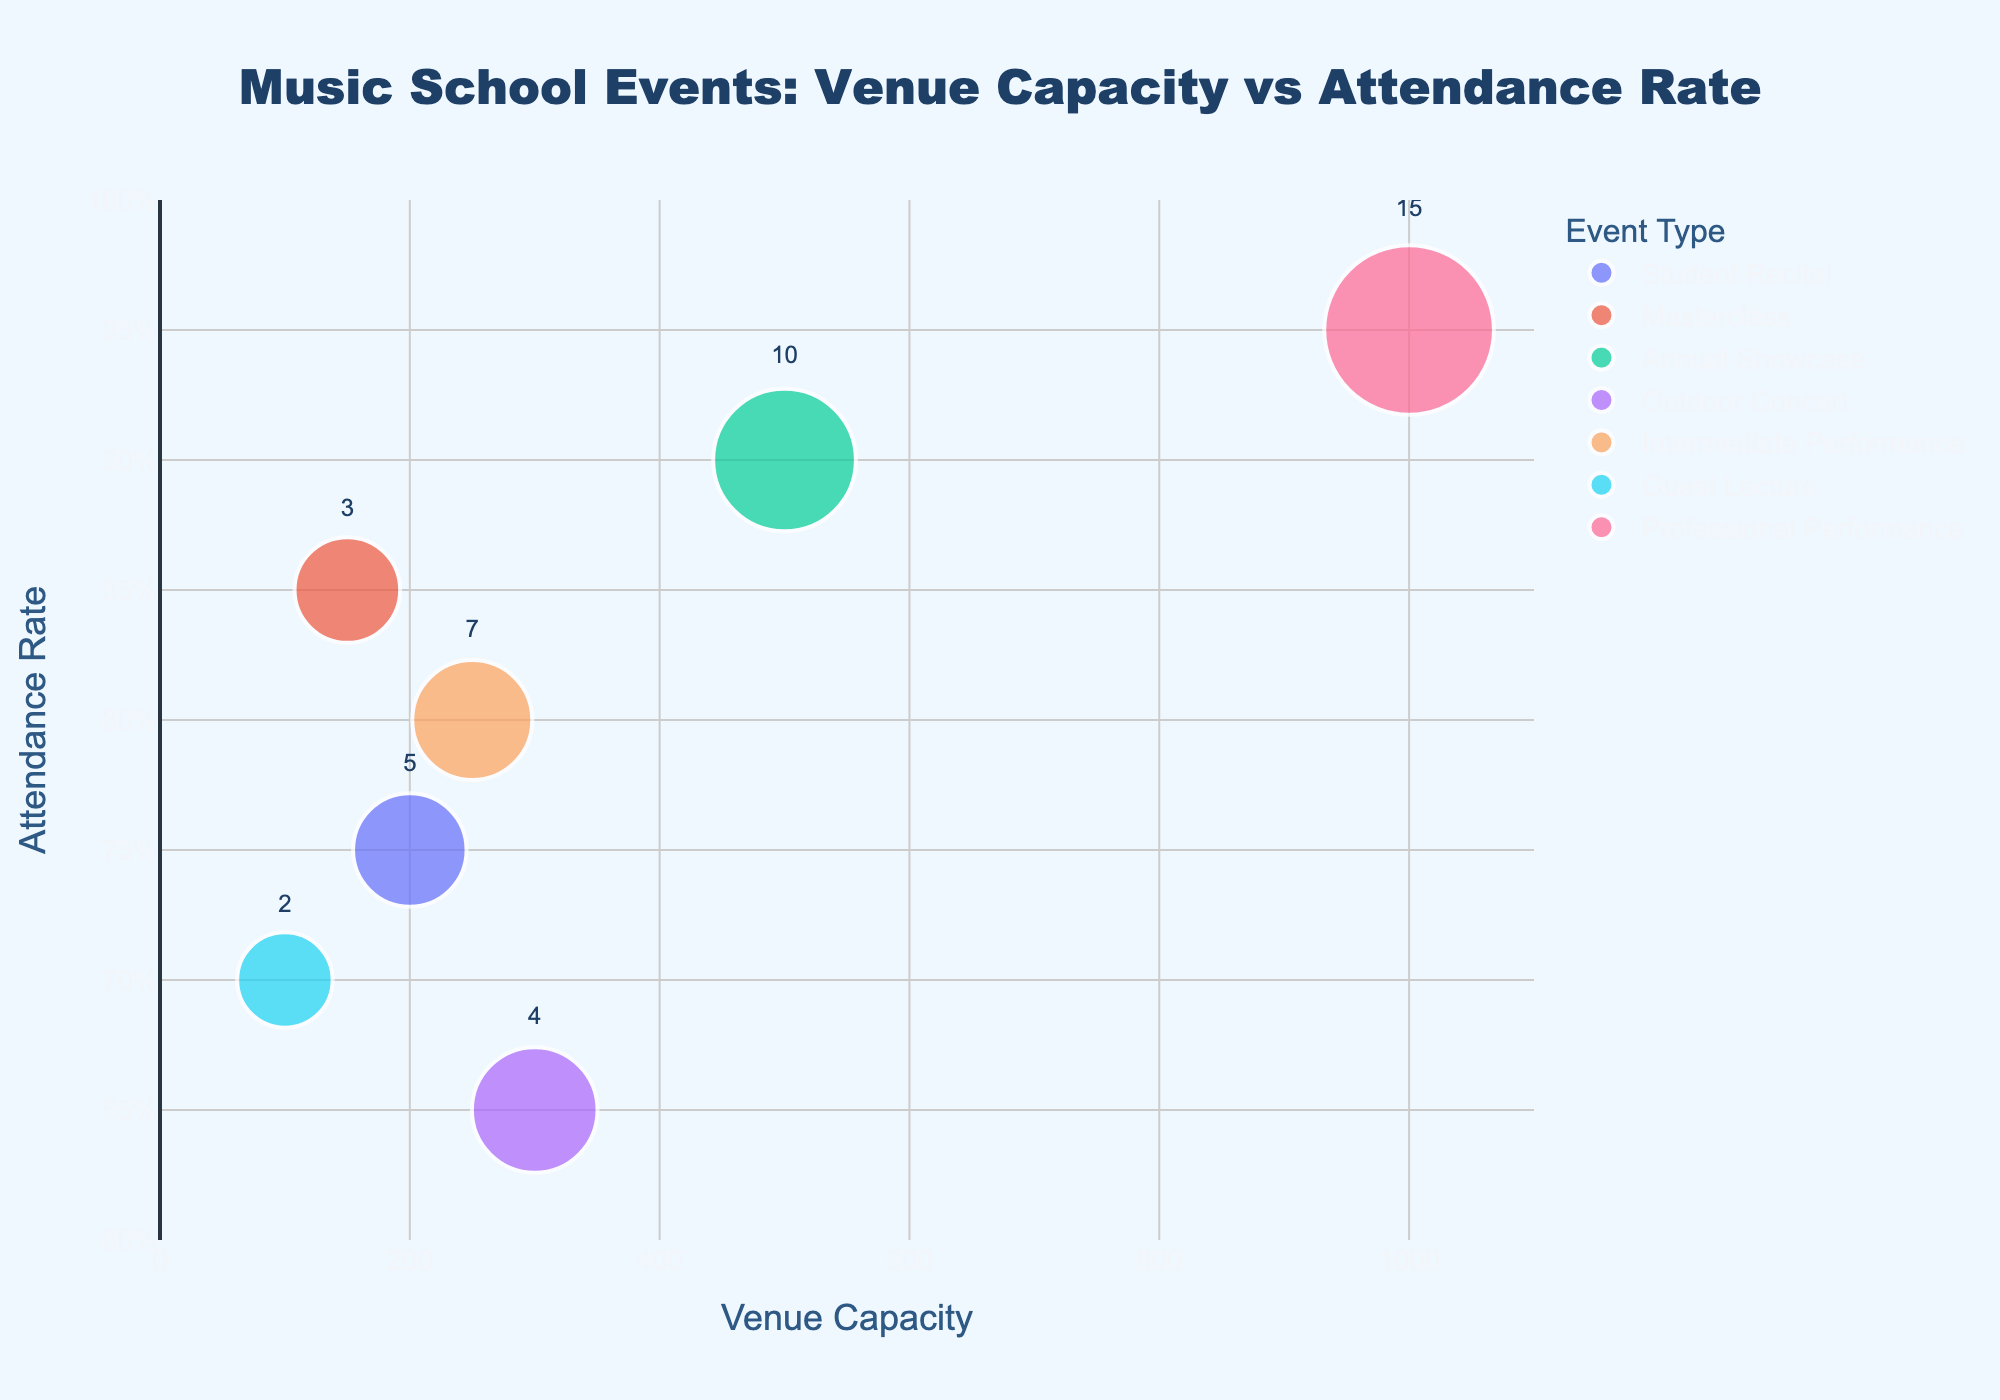What's the venue with the highest capacity? By examining the x-axis and the bubble sizes, the Concert Hall has the highest capacity at 1000.
Answer: Concert Hall Which event type has the highest attendance rate overall? The event type with the highest attendance rate is observed by looking at the y-axis. The Concert Hall's Professional Performance has the highest attendance rate at 0.95 (95%).
Answer: Professional Performance How many scholarship recipients are there for the event at the Local Park? The text label inside the bubble for Local Park, which is an Outdoor Concert, indicates the number of scholarship recipients. It shows 4.
Answer: 4 Which two venues have approximately the same attendance rate, and what is it? Observing the y-axis and the positions of the bubbles, the Community Center (Masterclass) and the High School Auditorium (Intermediate Performance) both have attendance rates around 0.80.
Answer: Community Center and High School Auditorium; 0.80 What is the difference in capacity between the Town Hall and the Community Center? The Town Hall has a capacity of 200 and the Community Center has a capacity of 150. The difference is calculated as 200 - 150 = 50.
Answer: 50 Which event type has the widest range of capacities? By comparing the x-axis range for each event type, Professional Performance (Concert Hall) ranges up to 1000 and the smallest venue Guest Lecture (Library Auditorium) ranges to 100.
Answer: Professional Performance On average, how many scholarship recipients are awarded per event? Sum the number of scholarship recipients for all events (5 + 3 + 10 + 4 + 7 + 2 + 15 = 46) and divide by the number of events (7). The average is 46 / 7 ≈ 6.57.
Answer: 6.57 Is there an inverse relationship between venue capacity and attendance rate? By inspecting the bubbles' positions on the plot, larger venues like the Concert Hall have higher attendance rates (0.95), which refutes an inverse relationship.
Answer: No Which two event types have the smallest difference in attendance rates? Comparing the y-axis data closely, the difference between the Intermediate Performance (High School Auditorium) at 0.80 and the Student Recital (Town Hall) at 0.75 is the smallest, which is 0.80 - 0.75 = 0.05.
Answer: Intermediate Performance and Student Recital How does the attendance rate of the Outdoor Concert compare to the Guest Lecture? The y-axis values for the Local Park (Outdoor Concert) and Library Auditorium (Guest Lecture) indicate their attendance rates are 0.65 and 0.70, respectively. The Outdoor Concert has a lower attendance rate.
Answer: Lower 